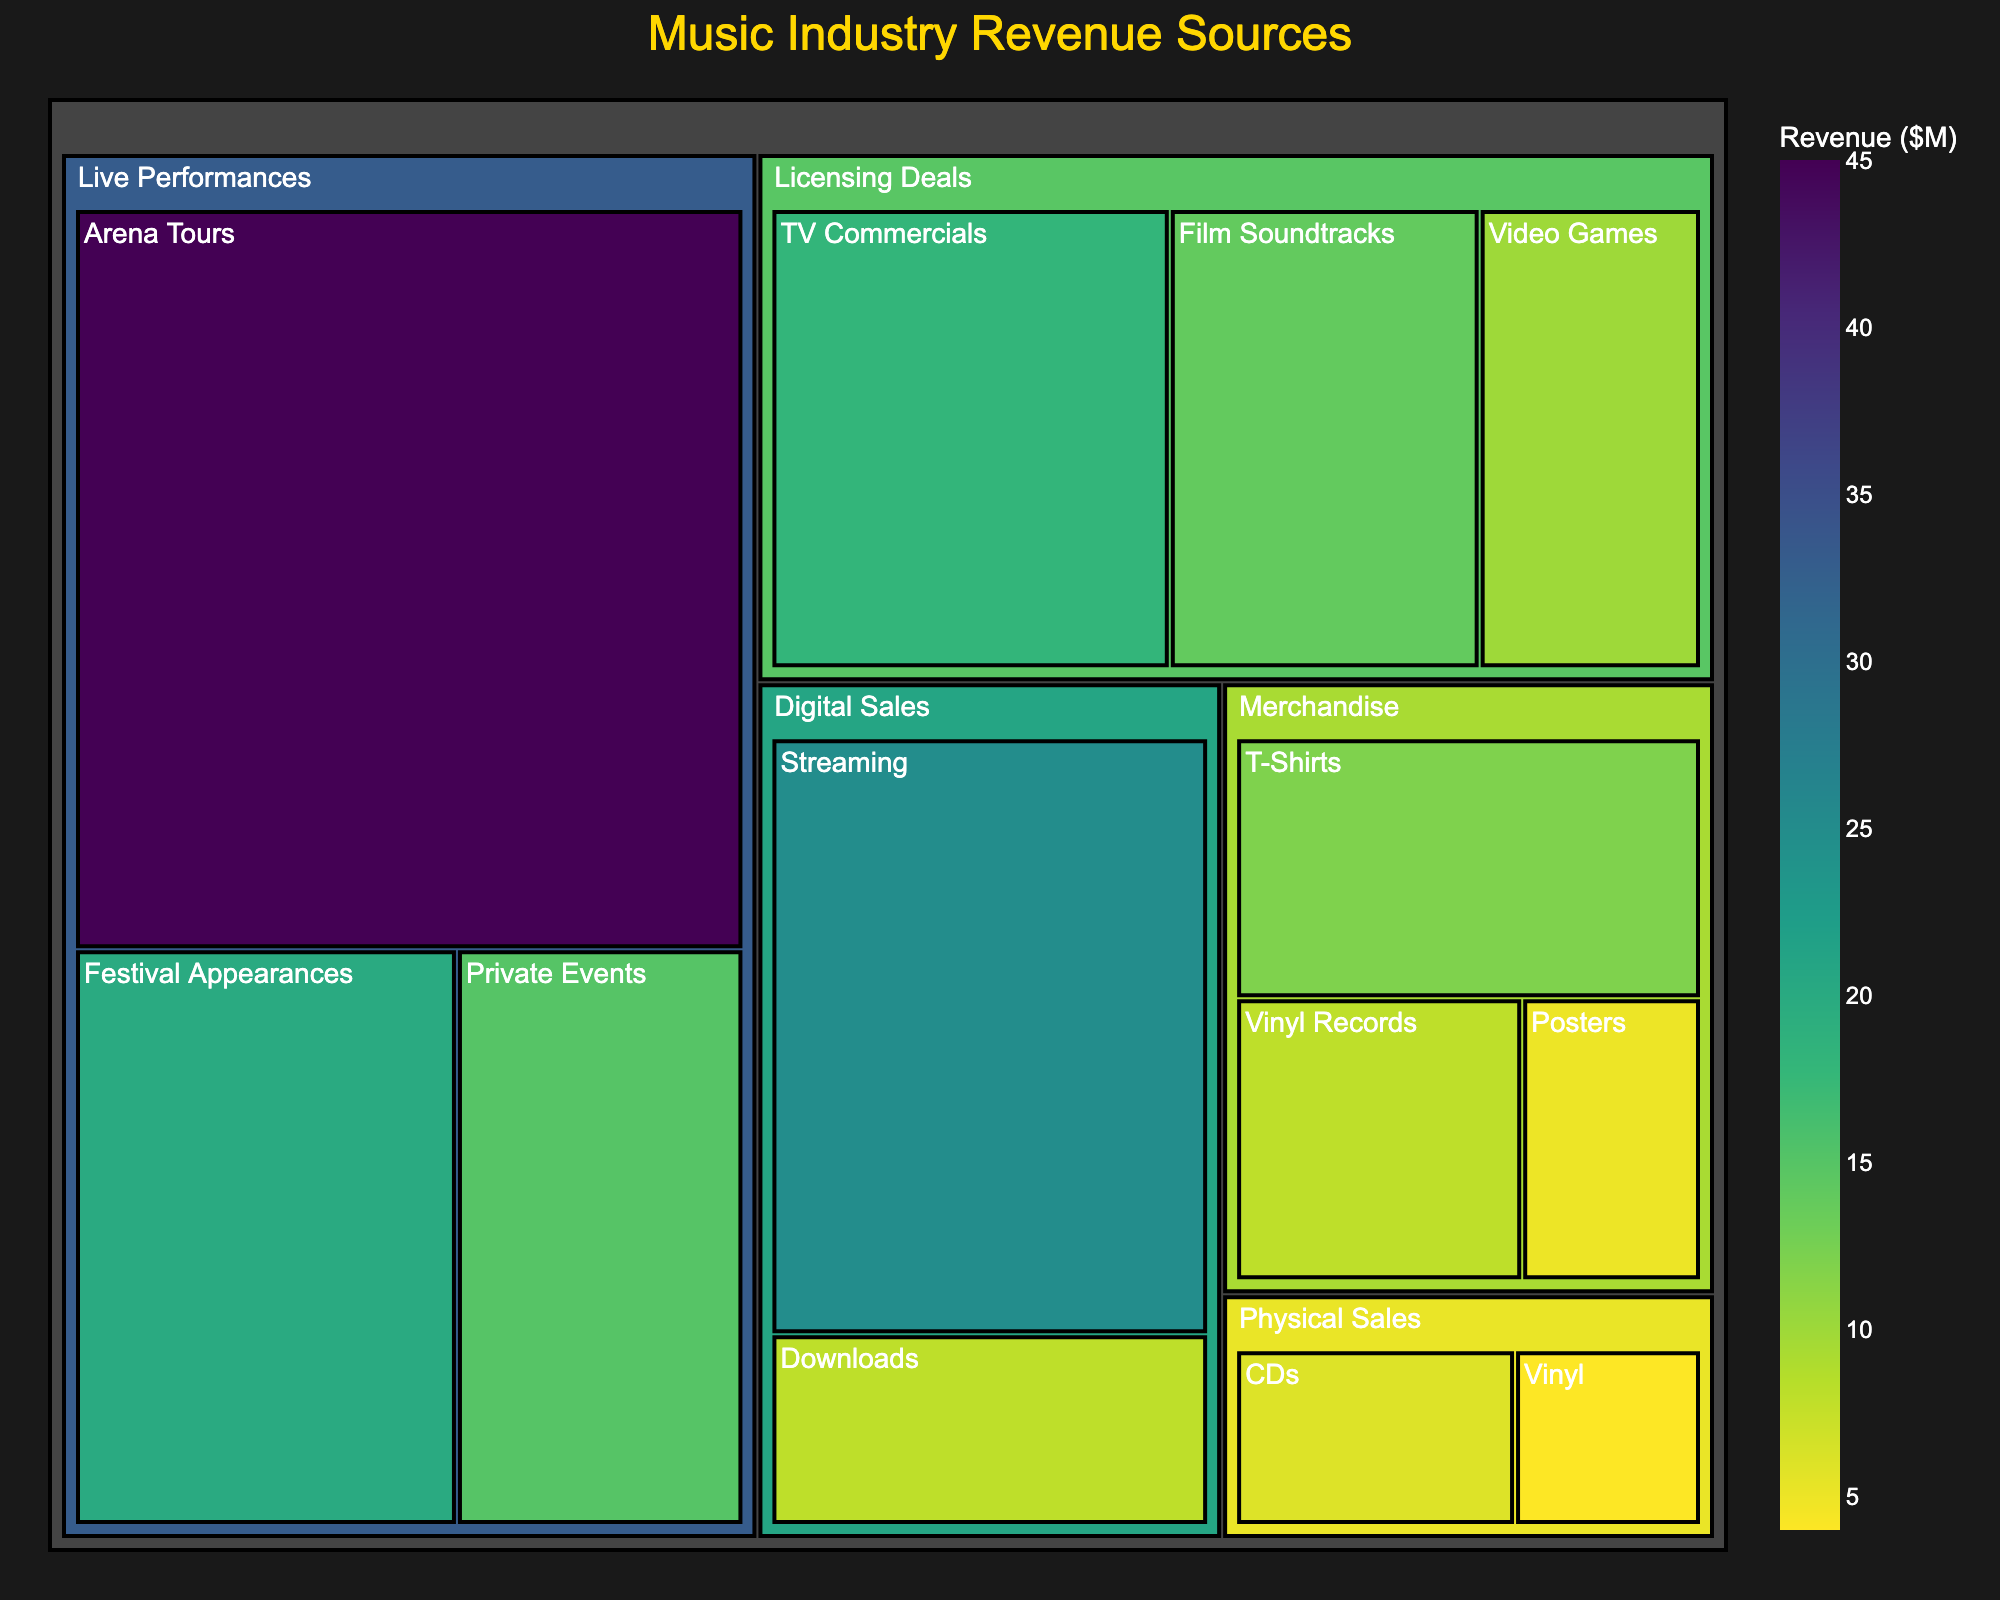What is the title of the figure? The title is clearly displayed at the top of the treemap.
Answer: Music Industry Revenue Sources Which category has the highest revenue? Identify the largest area in the treemap, which represents the category with the highest value.
Answer: Live Performances What is the total revenue from Live Performances? Sum the values of all subcategories under "Live Performances": Arena Tours (45) + Festival Appearances (20) + Private Events (15).
Answer: 80 Which subcategory under Licensing Deals has the lowest revenue? Locate the smallest segment under the "Licensing Deals" category in the treemap.
Answer: Video Games How does the revenue from T-Shirts compare to the revenue from Vinyl Records? Compare the segment sizes or values of T-Shirts (12) and Vinyl Records (8) in the treemap under the Merchandise category.
Answer: T-Shirts have higher revenue What is the combined revenue from Digital Sales and Physical Sales? Sum the values of all subcategories under "Digital Sales" and "Physical Sales".
Answer: 43 What is the average revenue of all subcategories under Licensing Deals? Sum all the values under Licensing Deals (TV Commercials: 18, Film Soundtracks: 14, Video Games: 10) and divide by the number of subcategories (3).
Answer: 14 Which category contributes more to the overall revenue: Merchandise or Digital Sales? Compare the total revenue values of Merchandise and Digital Sales.
Answer: Digital Sales Rank the subcategories under Live Performances from highest to lowest revenue. Compare the values of the subcategories under "Live Performances" and order them.
Answer: Arena Tours, Festival Appearances, Private Events Subtract the revenue of the smallest category from the largest category. Subtract the revenue of Physical Sales (10) from Live Performances (80).
Answer: 70 